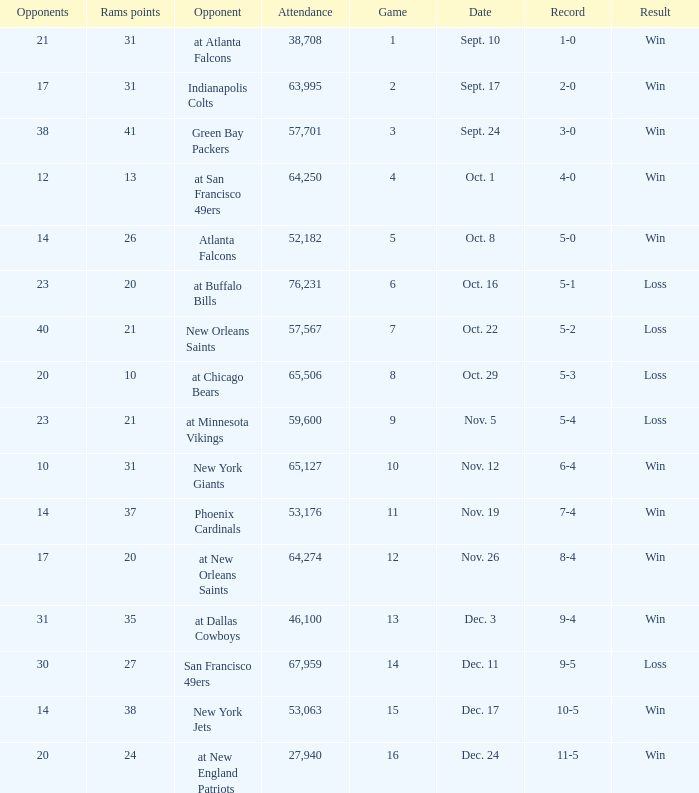What was the attendance where the record was 8-4? 64274.0. 